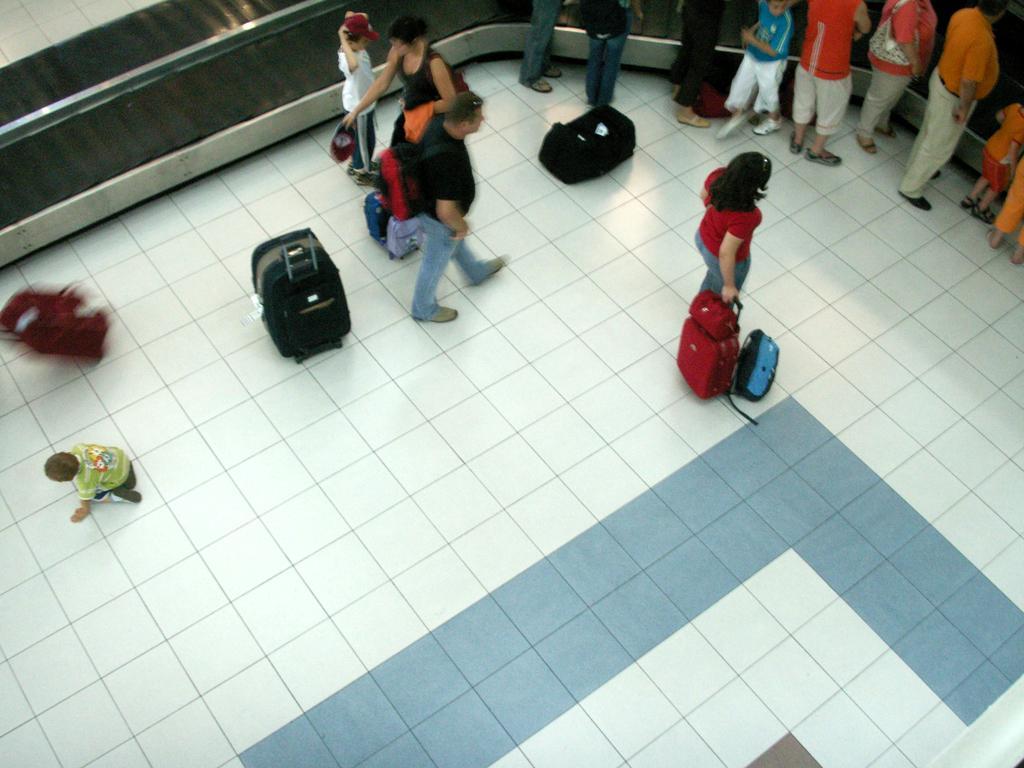Please provide a concise description of this image. In this image we can see people standing in a line. There are people walking. There are bags. In the background of the image there is a conveyor belt. At the bottom of the image there is floor. 